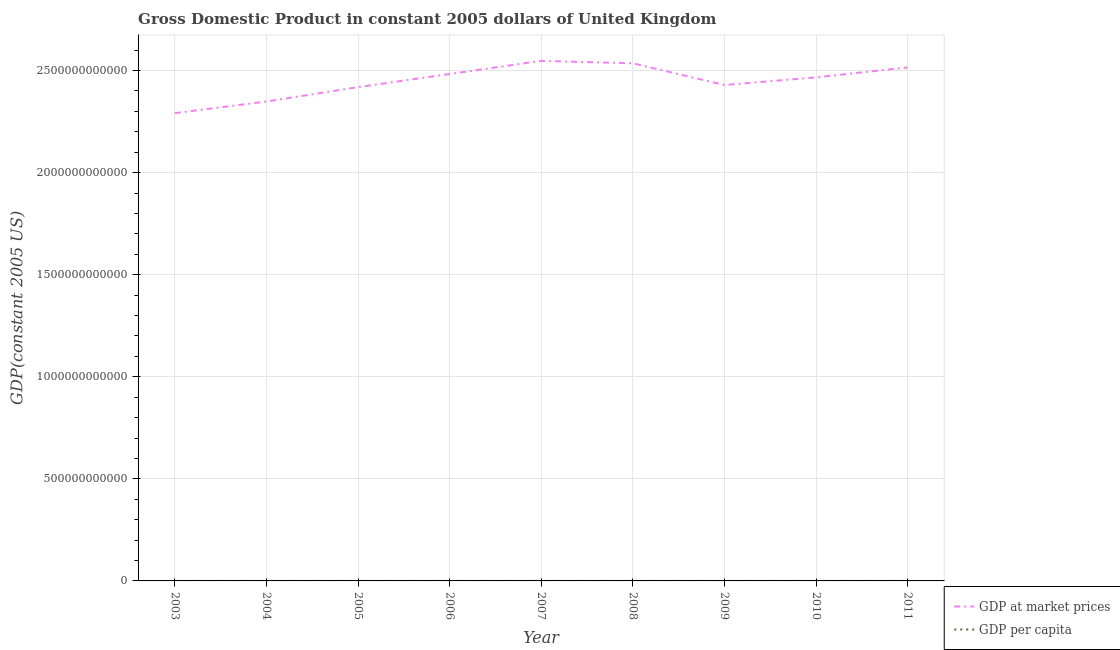How many different coloured lines are there?
Make the answer very short. 2. Is the number of lines equal to the number of legend labels?
Offer a very short reply. Yes. What is the gdp per capita in 2009?
Offer a terse response. 3.90e+04. Across all years, what is the maximum gdp at market prices?
Your answer should be very brief. 2.55e+12. Across all years, what is the minimum gdp at market prices?
Your answer should be very brief. 2.29e+12. In which year was the gdp per capita maximum?
Your answer should be compact. 2007. What is the total gdp per capita in the graph?
Ensure brevity in your answer.  3.59e+05. What is the difference between the gdp at market prices in 2004 and that in 2011?
Your response must be concise. -1.67e+11. What is the difference between the gdp at market prices in 2007 and the gdp per capita in 2005?
Offer a very short reply. 2.55e+12. What is the average gdp at market prices per year?
Your response must be concise. 2.45e+12. In the year 2003, what is the difference between the gdp per capita and gdp at market prices?
Your answer should be very brief. -2.29e+12. In how many years, is the gdp per capita greater than 2500000000000 US$?
Make the answer very short. 0. What is the ratio of the gdp at market prices in 2004 to that in 2006?
Your response must be concise. 0.95. What is the difference between the highest and the second highest gdp per capita?
Ensure brevity in your answer.  518.11. What is the difference between the highest and the lowest gdp per capita?
Keep it short and to the point. 3125.41. In how many years, is the gdp at market prices greater than the average gdp at market prices taken over all years?
Ensure brevity in your answer.  5. Is the gdp at market prices strictly greater than the gdp per capita over the years?
Your answer should be compact. Yes. What is the difference between two consecutive major ticks on the Y-axis?
Keep it short and to the point. 5.00e+11. Does the graph contain grids?
Provide a succinct answer. Yes. How many legend labels are there?
Offer a terse response. 2. What is the title of the graph?
Keep it short and to the point. Gross Domestic Product in constant 2005 dollars of United Kingdom. What is the label or title of the Y-axis?
Keep it short and to the point. GDP(constant 2005 US). What is the GDP(constant 2005 US) in GDP at market prices in 2003?
Make the answer very short. 2.29e+12. What is the GDP(constant 2005 US) of GDP per capita in 2003?
Your answer should be compact. 3.84e+04. What is the GDP(constant 2005 US) of GDP at market prices in 2004?
Keep it short and to the point. 2.35e+12. What is the GDP(constant 2005 US) of GDP per capita in 2004?
Provide a short and direct response. 3.92e+04. What is the GDP(constant 2005 US) of GDP at market prices in 2005?
Provide a short and direct response. 2.42e+12. What is the GDP(constant 2005 US) of GDP per capita in 2005?
Your answer should be very brief. 4.00e+04. What is the GDP(constant 2005 US) in GDP at market prices in 2006?
Provide a short and direct response. 2.48e+12. What is the GDP(constant 2005 US) in GDP per capita in 2006?
Make the answer very short. 4.08e+04. What is the GDP(constant 2005 US) in GDP at market prices in 2007?
Keep it short and to the point. 2.55e+12. What is the GDP(constant 2005 US) in GDP per capita in 2007?
Ensure brevity in your answer.  4.15e+04. What is the GDP(constant 2005 US) in GDP at market prices in 2008?
Your answer should be very brief. 2.54e+12. What is the GDP(constant 2005 US) in GDP per capita in 2008?
Make the answer very short. 4.10e+04. What is the GDP(constant 2005 US) of GDP at market prices in 2009?
Provide a succinct answer. 2.43e+12. What is the GDP(constant 2005 US) in GDP per capita in 2009?
Make the answer very short. 3.90e+04. What is the GDP(constant 2005 US) in GDP at market prices in 2010?
Provide a succinct answer. 2.47e+12. What is the GDP(constant 2005 US) of GDP per capita in 2010?
Offer a terse response. 3.93e+04. What is the GDP(constant 2005 US) of GDP at market prices in 2011?
Your answer should be compact. 2.52e+12. What is the GDP(constant 2005 US) in GDP per capita in 2011?
Offer a very short reply. 3.98e+04. Across all years, what is the maximum GDP(constant 2005 US) in GDP at market prices?
Offer a very short reply. 2.55e+12. Across all years, what is the maximum GDP(constant 2005 US) in GDP per capita?
Provide a succinct answer. 4.15e+04. Across all years, what is the minimum GDP(constant 2005 US) of GDP at market prices?
Offer a terse response. 2.29e+12. Across all years, what is the minimum GDP(constant 2005 US) in GDP per capita?
Ensure brevity in your answer.  3.84e+04. What is the total GDP(constant 2005 US) in GDP at market prices in the graph?
Ensure brevity in your answer.  2.20e+13. What is the total GDP(constant 2005 US) of GDP per capita in the graph?
Keep it short and to the point. 3.59e+05. What is the difference between the GDP(constant 2005 US) of GDP at market prices in 2003 and that in 2004?
Give a very brief answer. -5.70e+1. What is the difference between the GDP(constant 2005 US) in GDP per capita in 2003 and that in 2004?
Make the answer very short. -732.64. What is the difference between the GDP(constant 2005 US) in GDP at market prices in 2003 and that in 2005?
Provide a short and direct response. -1.27e+11. What is the difference between the GDP(constant 2005 US) in GDP per capita in 2003 and that in 2005?
Your answer should be compact. -1629.81. What is the difference between the GDP(constant 2005 US) in GDP at market prices in 2003 and that in 2006?
Your answer should be very brief. -1.92e+11. What is the difference between the GDP(constant 2005 US) in GDP per capita in 2003 and that in 2006?
Offer a terse response. -2394.72. What is the difference between the GDP(constant 2005 US) in GDP at market prices in 2003 and that in 2007?
Your answer should be very brief. -2.56e+11. What is the difference between the GDP(constant 2005 US) in GDP per capita in 2003 and that in 2007?
Your answer should be very brief. -3125.41. What is the difference between the GDP(constant 2005 US) in GDP at market prices in 2003 and that in 2008?
Provide a short and direct response. -2.44e+11. What is the difference between the GDP(constant 2005 US) of GDP per capita in 2003 and that in 2008?
Give a very brief answer. -2607.29. What is the difference between the GDP(constant 2005 US) in GDP at market prices in 2003 and that in 2009?
Your response must be concise. -1.38e+11. What is the difference between the GDP(constant 2005 US) of GDP per capita in 2003 and that in 2009?
Provide a succinct answer. -591.35. What is the difference between the GDP(constant 2005 US) of GDP at market prices in 2003 and that in 2010?
Offer a very short reply. -1.75e+11. What is the difference between the GDP(constant 2005 US) of GDP per capita in 2003 and that in 2010?
Provide a succinct answer. -882.88. What is the difference between the GDP(constant 2005 US) in GDP at market prices in 2003 and that in 2011?
Provide a succinct answer. -2.24e+11. What is the difference between the GDP(constant 2005 US) of GDP per capita in 2003 and that in 2011?
Make the answer very short. -1346. What is the difference between the GDP(constant 2005 US) of GDP at market prices in 2004 and that in 2005?
Your answer should be very brief. -7.04e+1. What is the difference between the GDP(constant 2005 US) in GDP per capita in 2004 and that in 2005?
Make the answer very short. -897.18. What is the difference between the GDP(constant 2005 US) in GDP at market prices in 2004 and that in 2006?
Provide a succinct answer. -1.35e+11. What is the difference between the GDP(constant 2005 US) in GDP per capita in 2004 and that in 2006?
Offer a very short reply. -1662.08. What is the difference between the GDP(constant 2005 US) in GDP at market prices in 2004 and that in 2007?
Provide a short and direct response. -1.99e+11. What is the difference between the GDP(constant 2005 US) of GDP per capita in 2004 and that in 2007?
Your answer should be very brief. -2392.77. What is the difference between the GDP(constant 2005 US) of GDP at market prices in 2004 and that in 2008?
Ensure brevity in your answer.  -1.87e+11. What is the difference between the GDP(constant 2005 US) in GDP per capita in 2004 and that in 2008?
Make the answer very short. -1874.65. What is the difference between the GDP(constant 2005 US) of GDP at market prices in 2004 and that in 2009?
Keep it short and to the point. -8.08e+1. What is the difference between the GDP(constant 2005 US) of GDP per capita in 2004 and that in 2009?
Provide a short and direct response. 141.29. What is the difference between the GDP(constant 2005 US) of GDP at market prices in 2004 and that in 2010?
Provide a succinct answer. -1.18e+11. What is the difference between the GDP(constant 2005 US) in GDP per capita in 2004 and that in 2010?
Provide a succinct answer. -150.24. What is the difference between the GDP(constant 2005 US) of GDP at market prices in 2004 and that in 2011?
Ensure brevity in your answer.  -1.67e+11. What is the difference between the GDP(constant 2005 US) of GDP per capita in 2004 and that in 2011?
Offer a terse response. -613.36. What is the difference between the GDP(constant 2005 US) in GDP at market prices in 2005 and that in 2006?
Give a very brief answer. -6.44e+1. What is the difference between the GDP(constant 2005 US) in GDP per capita in 2005 and that in 2006?
Offer a very short reply. -764.9. What is the difference between the GDP(constant 2005 US) in GDP at market prices in 2005 and that in 2007?
Provide a short and direct response. -1.29e+11. What is the difference between the GDP(constant 2005 US) of GDP per capita in 2005 and that in 2007?
Provide a short and direct response. -1495.59. What is the difference between the GDP(constant 2005 US) in GDP at market prices in 2005 and that in 2008?
Your response must be concise. -1.17e+11. What is the difference between the GDP(constant 2005 US) of GDP per capita in 2005 and that in 2008?
Your response must be concise. -977.48. What is the difference between the GDP(constant 2005 US) in GDP at market prices in 2005 and that in 2009?
Your response must be concise. -1.04e+1. What is the difference between the GDP(constant 2005 US) of GDP per capita in 2005 and that in 2009?
Provide a short and direct response. 1038.47. What is the difference between the GDP(constant 2005 US) of GDP at market prices in 2005 and that in 2010?
Your answer should be compact. -4.78e+1. What is the difference between the GDP(constant 2005 US) of GDP per capita in 2005 and that in 2010?
Offer a very short reply. 746.94. What is the difference between the GDP(constant 2005 US) of GDP at market prices in 2005 and that in 2011?
Provide a short and direct response. -9.65e+1. What is the difference between the GDP(constant 2005 US) of GDP per capita in 2005 and that in 2011?
Ensure brevity in your answer.  283.81. What is the difference between the GDP(constant 2005 US) in GDP at market prices in 2006 and that in 2007?
Provide a succinct answer. -6.42e+1. What is the difference between the GDP(constant 2005 US) of GDP per capita in 2006 and that in 2007?
Offer a terse response. -730.69. What is the difference between the GDP(constant 2005 US) of GDP at market prices in 2006 and that in 2008?
Your response must be concise. -5.23e+1. What is the difference between the GDP(constant 2005 US) of GDP per capita in 2006 and that in 2008?
Your answer should be compact. -212.57. What is the difference between the GDP(constant 2005 US) of GDP at market prices in 2006 and that in 2009?
Offer a terse response. 5.40e+1. What is the difference between the GDP(constant 2005 US) in GDP per capita in 2006 and that in 2009?
Your response must be concise. 1803.37. What is the difference between the GDP(constant 2005 US) in GDP at market prices in 2006 and that in 2010?
Your response must be concise. 1.66e+1. What is the difference between the GDP(constant 2005 US) of GDP per capita in 2006 and that in 2010?
Provide a short and direct response. 1511.84. What is the difference between the GDP(constant 2005 US) in GDP at market prices in 2006 and that in 2011?
Give a very brief answer. -3.21e+1. What is the difference between the GDP(constant 2005 US) of GDP per capita in 2006 and that in 2011?
Give a very brief answer. 1048.72. What is the difference between the GDP(constant 2005 US) of GDP at market prices in 2007 and that in 2008?
Keep it short and to the point. 1.19e+1. What is the difference between the GDP(constant 2005 US) of GDP per capita in 2007 and that in 2008?
Keep it short and to the point. 518.11. What is the difference between the GDP(constant 2005 US) in GDP at market prices in 2007 and that in 2009?
Keep it short and to the point. 1.18e+11. What is the difference between the GDP(constant 2005 US) of GDP per capita in 2007 and that in 2009?
Your answer should be compact. 2534.06. What is the difference between the GDP(constant 2005 US) of GDP at market prices in 2007 and that in 2010?
Your answer should be compact. 8.08e+1. What is the difference between the GDP(constant 2005 US) in GDP per capita in 2007 and that in 2010?
Provide a short and direct response. 2242.53. What is the difference between the GDP(constant 2005 US) of GDP at market prices in 2007 and that in 2011?
Provide a short and direct response. 3.21e+1. What is the difference between the GDP(constant 2005 US) in GDP per capita in 2007 and that in 2011?
Provide a succinct answer. 1779.4. What is the difference between the GDP(constant 2005 US) in GDP at market prices in 2008 and that in 2009?
Offer a terse response. 1.06e+11. What is the difference between the GDP(constant 2005 US) of GDP per capita in 2008 and that in 2009?
Offer a very short reply. 2015.94. What is the difference between the GDP(constant 2005 US) in GDP at market prices in 2008 and that in 2010?
Provide a succinct answer. 6.89e+1. What is the difference between the GDP(constant 2005 US) in GDP per capita in 2008 and that in 2010?
Your answer should be very brief. 1724.42. What is the difference between the GDP(constant 2005 US) of GDP at market prices in 2008 and that in 2011?
Ensure brevity in your answer.  2.02e+1. What is the difference between the GDP(constant 2005 US) in GDP per capita in 2008 and that in 2011?
Your answer should be compact. 1261.29. What is the difference between the GDP(constant 2005 US) in GDP at market prices in 2009 and that in 2010?
Your answer should be very brief. -3.74e+1. What is the difference between the GDP(constant 2005 US) of GDP per capita in 2009 and that in 2010?
Provide a short and direct response. -291.53. What is the difference between the GDP(constant 2005 US) in GDP at market prices in 2009 and that in 2011?
Provide a short and direct response. -8.61e+1. What is the difference between the GDP(constant 2005 US) in GDP per capita in 2009 and that in 2011?
Provide a succinct answer. -754.65. What is the difference between the GDP(constant 2005 US) in GDP at market prices in 2010 and that in 2011?
Your response must be concise. -4.87e+1. What is the difference between the GDP(constant 2005 US) of GDP per capita in 2010 and that in 2011?
Give a very brief answer. -463.13. What is the difference between the GDP(constant 2005 US) of GDP at market prices in 2003 and the GDP(constant 2005 US) of GDP per capita in 2004?
Provide a short and direct response. 2.29e+12. What is the difference between the GDP(constant 2005 US) of GDP at market prices in 2003 and the GDP(constant 2005 US) of GDP per capita in 2005?
Offer a very short reply. 2.29e+12. What is the difference between the GDP(constant 2005 US) of GDP at market prices in 2003 and the GDP(constant 2005 US) of GDP per capita in 2006?
Your response must be concise. 2.29e+12. What is the difference between the GDP(constant 2005 US) in GDP at market prices in 2003 and the GDP(constant 2005 US) in GDP per capita in 2007?
Keep it short and to the point. 2.29e+12. What is the difference between the GDP(constant 2005 US) of GDP at market prices in 2003 and the GDP(constant 2005 US) of GDP per capita in 2008?
Your answer should be very brief. 2.29e+12. What is the difference between the GDP(constant 2005 US) in GDP at market prices in 2003 and the GDP(constant 2005 US) in GDP per capita in 2009?
Provide a succinct answer. 2.29e+12. What is the difference between the GDP(constant 2005 US) of GDP at market prices in 2003 and the GDP(constant 2005 US) of GDP per capita in 2010?
Offer a terse response. 2.29e+12. What is the difference between the GDP(constant 2005 US) in GDP at market prices in 2003 and the GDP(constant 2005 US) in GDP per capita in 2011?
Provide a short and direct response. 2.29e+12. What is the difference between the GDP(constant 2005 US) in GDP at market prices in 2004 and the GDP(constant 2005 US) in GDP per capita in 2005?
Your answer should be compact. 2.35e+12. What is the difference between the GDP(constant 2005 US) in GDP at market prices in 2004 and the GDP(constant 2005 US) in GDP per capita in 2006?
Keep it short and to the point. 2.35e+12. What is the difference between the GDP(constant 2005 US) of GDP at market prices in 2004 and the GDP(constant 2005 US) of GDP per capita in 2007?
Offer a terse response. 2.35e+12. What is the difference between the GDP(constant 2005 US) in GDP at market prices in 2004 and the GDP(constant 2005 US) in GDP per capita in 2008?
Make the answer very short. 2.35e+12. What is the difference between the GDP(constant 2005 US) in GDP at market prices in 2004 and the GDP(constant 2005 US) in GDP per capita in 2009?
Ensure brevity in your answer.  2.35e+12. What is the difference between the GDP(constant 2005 US) in GDP at market prices in 2004 and the GDP(constant 2005 US) in GDP per capita in 2010?
Offer a very short reply. 2.35e+12. What is the difference between the GDP(constant 2005 US) of GDP at market prices in 2004 and the GDP(constant 2005 US) of GDP per capita in 2011?
Provide a short and direct response. 2.35e+12. What is the difference between the GDP(constant 2005 US) in GDP at market prices in 2005 and the GDP(constant 2005 US) in GDP per capita in 2006?
Your answer should be very brief. 2.42e+12. What is the difference between the GDP(constant 2005 US) of GDP at market prices in 2005 and the GDP(constant 2005 US) of GDP per capita in 2007?
Provide a succinct answer. 2.42e+12. What is the difference between the GDP(constant 2005 US) of GDP at market prices in 2005 and the GDP(constant 2005 US) of GDP per capita in 2008?
Your answer should be very brief. 2.42e+12. What is the difference between the GDP(constant 2005 US) of GDP at market prices in 2005 and the GDP(constant 2005 US) of GDP per capita in 2009?
Give a very brief answer. 2.42e+12. What is the difference between the GDP(constant 2005 US) of GDP at market prices in 2005 and the GDP(constant 2005 US) of GDP per capita in 2010?
Your answer should be very brief. 2.42e+12. What is the difference between the GDP(constant 2005 US) of GDP at market prices in 2005 and the GDP(constant 2005 US) of GDP per capita in 2011?
Your answer should be very brief. 2.42e+12. What is the difference between the GDP(constant 2005 US) in GDP at market prices in 2006 and the GDP(constant 2005 US) in GDP per capita in 2007?
Your response must be concise. 2.48e+12. What is the difference between the GDP(constant 2005 US) in GDP at market prices in 2006 and the GDP(constant 2005 US) in GDP per capita in 2008?
Keep it short and to the point. 2.48e+12. What is the difference between the GDP(constant 2005 US) of GDP at market prices in 2006 and the GDP(constant 2005 US) of GDP per capita in 2009?
Your answer should be very brief. 2.48e+12. What is the difference between the GDP(constant 2005 US) in GDP at market prices in 2006 and the GDP(constant 2005 US) in GDP per capita in 2010?
Provide a succinct answer. 2.48e+12. What is the difference between the GDP(constant 2005 US) in GDP at market prices in 2006 and the GDP(constant 2005 US) in GDP per capita in 2011?
Provide a succinct answer. 2.48e+12. What is the difference between the GDP(constant 2005 US) in GDP at market prices in 2007 and the GDP(constant 2005 US) in GDP per capita in 2008?
Offer a terse response. 2.55e+12. What is the difference between the GDP(constant 2005 US) in GDP at market prices in 2007 and the GDP(constant 2005 US) in GDP per capita in 2009?
Your answer should be very brief. 2.55e+12. What is the difference between the GDP(constant 2005 US) of GDP at market prices in 2007 and the GDP(constant 2005 US) of GDP per capita in 2010?
Make the answer very short. 2.55e+12. What is the difference between the GDP(constant 2005 US) in GDP at market prices in 2007 and the GDP(constant 2005 US) in GDP per capita in 2011?
Give a very brief answer. 2.55e+12. What is the difference between the GDP(constant 2005 US) of GDP at market prices in 2008 and the GDP(constant 2005 US) of GDP per capita in 2009?
Make the answer very short. 2.54e+12. What is the difference between the GDP(constant 2005 US) in GDP at market prices in 2008 and the GDP(constant 2005 US) in GDP per capita in 2010?
Provide a succinct answer. 2.54e+12. What is the difference between the GDP(constant 2005 US) of GDP at market prices in 2008 and the GDP(constant 2005 US) of GDP per capita in 2011?
Provide a short and direct response. 2.54e+12. What is the difference between the GDP(constant 2005 US) of GDP at market prices in 2009 and the GDP(constant 2005 US) of GDP per capita in 2010?
Give a very brief answer. 2.43e+12. What is the difference between the GDP(constant 2005 US) in GDP at market prices in 2009 and the GDP(constant 2005 US) in GDP per capita in 2011?
Your answer should be very brief. 2.43e+12. What is the difference between the GDP(constant 2005 US) of GDP at market prices in 2010 and the GDP(constant 2005 US) of GDP per capita in 2011?
Your answer should be compact. 2.47e+12. What is the average GDP(constant 2005 US) of GDP at market prices per year?
Your answer should be compact. 2.45e+12. What is the average GDP(constant 2005 US) of GDP per capita per year?
Make the answer very short. 3.99e+04. In the year 2003, what is the difference between the GDP(constant 2005 US) in GDP at market prices and GDP(constant 2005 US) in GDP per capita?
Offer a very short reply. 2.29e+12. In the year 2004, what is the difference between the GDP(constant 2005 US) of GDP at market prices and GDP(constant 2005 US) of GDP per capita?
Your answer should be very brief. 2.35e+12. In the year 2005, what is the difference between the GDP(constant 2005 US) of GDP at market prices and GDP(constant 2005 US) of GDP per capita?
Ensure brevity in your answer.  2.42e+12. In the year 2006, what is the difference between the GDP(constant 2005 US) of GDP at market prices and GDP(constant 2005 US) of GDP per capita?
Provide a succinct answer. 2.48e+12. In the year 2007, what is the difference between the GDP(constant 2005 US) in GDP at market prices and GDP(constant 2005 US) in GDP per capita?
Offer a terse response. 2.55e+12. In the year 2008, what is the difference between the GDP(constant 2005 US) in GDP at market prices and GDP(constant 2005 US) in GDP per capita?
Your answer should be very brief. 2.54e+12. In the year 2009, what is the difference between the GDP(constant 2005 US) of GDP at market prices and GDP(constant 2005 US) of GDP per capita?
Offer a terse response. 2.43e+12. In the year 2010, what is the difference between the GDP(constant 2005 US) in GDP at market prices and GDP(constant 2005 US) in GDP per capita?
Offer a terse response. 2.47e+12. In the year 2011, what is the difference between the GDP(constant 2005 US) of GDP at market prices and GDP(constant 2005 US) of GDP per capita?
Offer a very short reply. 2.52e+12. What is the ratio of the GDP(constant 2005 US) of GDP at market prices in 2003 to that in 2004?
Provide a succinct answer. 0.98. What is the ratio of the GDP(constant 2005 US) of GDP per capita in 2003 to that in 2004?
Offer a terse response. 0.98. What is the ratio of the GDP(constant 2005 US) in GDP at market prices in 2003 to that in 2005?
Keep it short and to the point. 0.95. What is the ratio of the GDP(constant 2005 US) in GDP per capita in 2003 to that in 2005?
Ensure brevity in your answer.  0.96. What is the ratio of the GDP(constant 2005 US) in GDP at market prices in 2003 to that in 2006?
Keep it short and to the point. 0.92. What is the ratio of the GDP(constant 2005 US) of GDP per capita in 2003 to that in 2006?
Give a very brief answer. 0.94. What is the ratio of the GDP(constant 2005 US) of GDP at market prices in 2003 to that in 2007?
Keep it short and to the point. 0.9. What is the ratio of the GDP(constant 2005 US) in GDP per capita in 2003 to that in 2007?
Your answer should be compact. 0.92. What is the ratio of the GDP(constant 2005 US) of GDP at market prices in 2003 to that in 2008?
Give a very brief answer. 0.9. What is the ratio of the GDP(constant 2005 US) of GDP per capita in 2003 to that in 2008?
Offer a very short reply. 0.94. What is the ratio of the GDP(constant 2005 US) of GDP at market prices in 2003 to that in 2009?
Make the answer very short. 0.94. What is the ratio of the GDP(constant 2005 US) in GDP at market prices in 2003 to that in 2010?
Your answer should be compact. 0.93. What is the ratio of the GDP(constant 2005 US) of GDP per capita in 2003 to that in 2010?
Keep it short and to the point. 0.98. What is the ratio of the GDP(constant 2005 US) in GDP at market prices in 2003 to that in 2011?
Offer a very short reply. 0.91. What is the ratio of the GDP(constant 2005 US) of GDP per capita in 2003 to that in 2011?
Your answer should be compact. 0.97. What is the ratio of the GDP(constant 2005 US) in GDP at market prices in 2004 to that in 2005?
Make the answer very short. 0.97. What is the ratio of the GDP(constant 2005 US) of GDP per capita in 2004 to that in 2005?
Give a very brief answer. 0.98. What is the ratio of the GDP(constant 2005 US) of GDP at market prices in 2004 to that in 2006?
Make the answer very short. 0.95. What is the ratio of the GDP(constant 2005 US) in GDP per capita in 2004 to that in 2006?
Ensure brevity in your answer.  0.96. What is the ratio of the GDP(constant 2005 US) in GDP at market prices in 2004 to that in 2007?
Your answer should be very brief. 0.92. What is the ratio of the GDP(constant 2005 US) in GDP per capita in 2004 to that in 2007?
Offer a terse response. 0.94. What is the ratio of the GDP(constant 2005 US) of GDP at market prices in 2004 to that in 2008?
Your response must be concise. 0.93. What is the ratio of the GDP(constant 2005 US) in GDP per capita in 2004 to that in 2008?
Give a very brief answer. 0.95. What is the ratio of the GDP(constant 2005 US) in GDP at market prices in 2004 to that in 2009?
Provide a short and direct response. 0.97. What is the ratio of the GDP(constant 2005 US) in GDP at market prices in 2004 to that in 2010?
Your answer should be very brief. 0.95. What is the ratio of the GDP(constant 2005 US) in GDP per capita in 2004 to that in 2010?
Offer a very short reply. 1. What is the ratio of the GDP(constant 2005 US) of GDP at market prices in 2004 to that in 2011?
Offer a terse response. 0.93. What is the ratio of the GDP(constant 2005 US) in GDP per capita in 2004 to that in 2011?
Make the answer very short. 0.98. What is the ratio of the GDP(constant 2005 US) in GDP at market prices in 2005 to that in 2006?
Provide a short and direct response. 0.97. What is the ratio of the GDP(constant 2005 US) of GDP per capita in 2005 to that in 2006?
Give a very brief answer. 0.98. What is the ratio of the GDP(constant 2005 US) in GDP at market prices in 2005 to that in 2007?
Your answer should be very brief. 0.95. What is the ratio of the GDP(constant 2005 US) of GDP per capita in 2005 to that in 2007?
Keep it short and to the point. 0.96. What is the ratio of the GDP(constant 2005 US) in GDP at market prices in 2005 to that in 2008?
Keep it short and to the point. 0.95. What is the ratio of the GDP(constant 2005 US) of GDP per capita in 2005 to that in 2008?
Make the answer very short. 0.98. What is the ratio of the GDP(constant 2005 US) of GDP at market prices in 2005 to that in 2009?
Offer a very short reply. 1. What is the ratio of the GDP(constant 2005 US) of GDP per capita in 2005 to that in 2009?
Provide a succinct answer. 1.03. What is the ratio of the GDP(constant 2005 US) in GDP at market prices in 2005 to that in 2010?
Provide a short and direct response. 0.98. What is the ratio of the GDP(constant 2005 US) in GDP at market prices in 2005 to that in 2011?
Offer a very short reply. 0.96. What is the ratio of the GDP(constant 2005 US) of GDP per capita in 2005 to that in 2011?
Give a very brief answer. 1.01. What is the ratio of the GDP(constant 2005 US) in GDP at market prices in 2006 to that in 2007?
Give a very brief answer. 0.97. What is the ratio of the GDP(constant 2005 US) of GDP per capita in 2006 to that in 2007?
Offer a very short reply. 0.98. What is the ratio of the GDP(constant 2005 US) of GDP at market prices in 2006 to that in 2008?
Give a very brief answer. 0.98. What is the ratio of the GDP(constant 2005 US) in GDP per capita in 2006 to that in 2008?
Your answer should be compact. 0.99. What is the ratio of the GDP(constant 2005 US) in GDP at market prices in 2006 to that in 2009?
Ensure brevity in your answer.  1.02. What is the ratio of the GDP(constant 2005 US) in GDP per capita in 2006 to that in 2009?
Offer a very short reply. 1.05. What is the ratio of the GDP(constant 2005 US) of GDP at market prices in 2006 to that in 2010?
Offer a terse response. 1.01. What is the ratio of the GDP(constant 2005 US) of GDP at market prices in 2006 to that in 2011?
Your response must be concise. 0.99. What is the ratio of the GDP(constant 2005 US) of GDP per capita in 2006 to that in 2011?
Provide a succinct answer. 1.03. What is the ratio of the GDP(constant 2005 US) in GDP per capita in 2007 to that in 2008?
Offer a very short reply. 1.01. What is the ratio of the GDP(constant 2005 US) in GDP at market prices in 2007 to that in 2009?
Give a very brief answer. 1.05. What is the ratio of the GDP(constant 2005 US) of GDP per capita in 2007 to that in 2009?
Offer a terse response. 1.06. What is the ratio of the GDP(constant 2005 US) of GDP at market prices in 2007 to that in 2010?
Make the answer very short. 1.03. What is the ratio of the GDP(constant 2005 US) of GDP per capita in 2007 to that in 2010?
Provide a succinct answer. 1.06. What is the ratio of the GDP(constant 2005 US) in GDP at market prices in 2007 to that in 2011?
Your answer should be very brief. 1.01. What is the ratio of the GDP(constant 2005 US) in GDP per capita in 2007 to that in 2011?
Offer a terse response. 1.04. What is the ratio of the GDP(constant 2005 US) in GDP at market prices in 2008 to that in 2009?
Give a very brief answer. 1.04. What is the ratio of the GDP(constant 2005 US) in GDP per capita in 2008 to that in 2009?
Make the answer very short. 1.05. What is the ratio of the GDP(constant 2005 US) of GDP at market prices in 2008 to that in 2010?
Offer a very short reply. 1.03. What is the ratio of the GDP(constant 2005 US) of GDP per capita in 2008 to that in 2010?
Your answer should be very brief. 1.04. What is the ratio of the GDP(constant 2005 US) in GDP per capita in 2008 to that in 2011?
Keep it short and to the point. 1.03. What is the ratio of the GDP(constant 2005 US) of GDP at market prices in 2009 to that in 2010?
Your answer should be compact. 0.98. What is the ratio of the GDP(constant 2005 US) in GDP per capita in 2009 to that in 2010?
Your answer should be compact. 0.99. What is the ratio of the GDP(constant 2005 US) in GDP at market prices in 2009 to that in 2011?
Your answer should be very brief. 0.97. What is the ratio of the GDP(constant 2005 US) in GDP per capita in 2009 to that in 2011?
Offer a terse response. 0.98. What is the ratio of the GDP(constant 2005 US) in GDP at market prices in 2010 to that in 2011?
Offer a terse response. 0.98. What is the ratio of the GDP(constant 2005 US) of GDP per capita in 2010 to that in 2011?
Keep it short and to the point. 0.99. What is the difference between the highest and the second highest GDP(constant 2005 US) in GDP at market prices?
Keep it short and to the point. 1.19e+1. What is the difference between the highest and the second highest GDP(constant 2005 US) in GDP per capita?
Ensure brevity in your answer.  518.11. What is the difference between the highest and the lowest GDP(constant 2005 US) of GDP at market prices?
Your response must be concise. 2.56e+11. What is the difference between the highest and the lowest GDP(constant 2005 US) in GDP per capita?
Your answer should be very brief. 3125.41. 